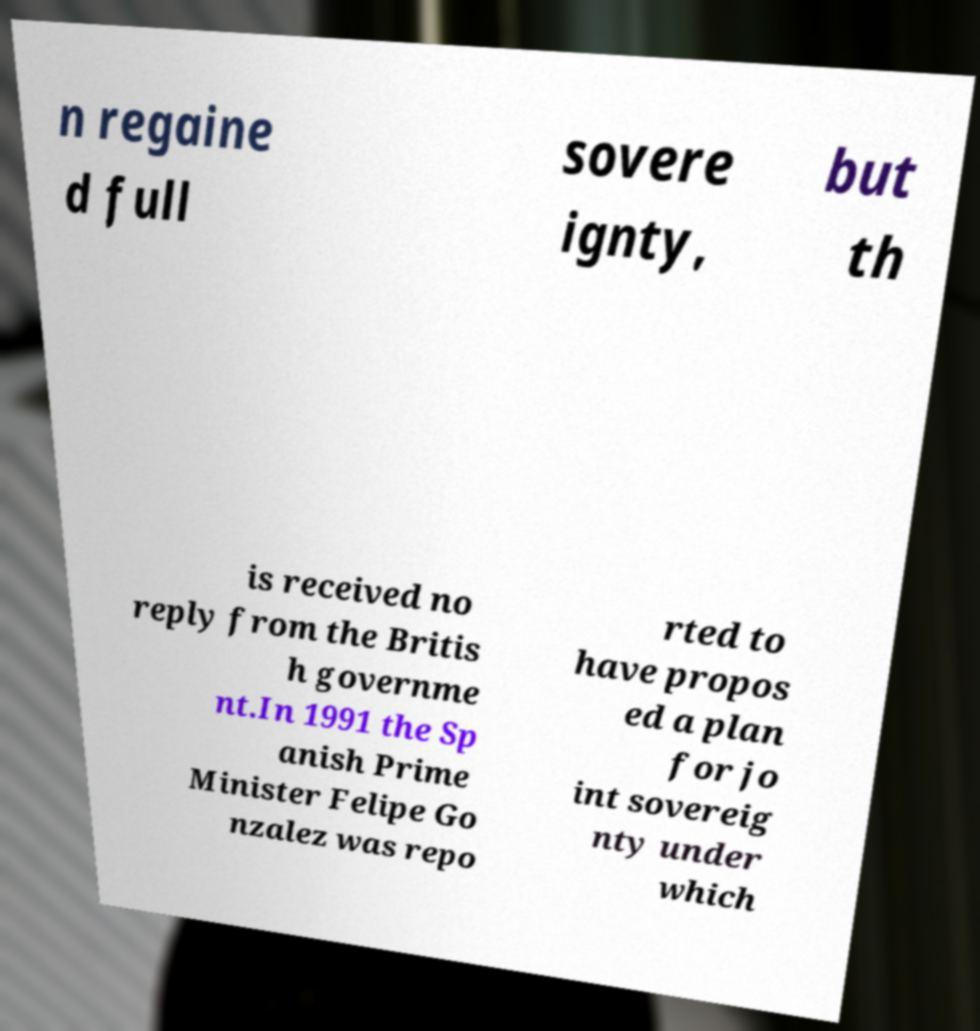Can you accurately transcribe the text from the provided image for me? n regaine d full sovere ignty, but th is received no reply from the Britis h governme nt.In 1991 the Sp anish Prime Minister Felipe Go nzalez was repo rted to have propos ed a plan for jo int sovereig nty under which 